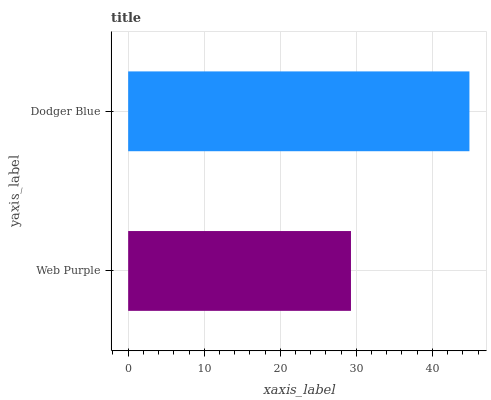Is Web Purple the minimum?
Answer yes or no. Yes. Is Dodger Blue the maximum?
Answer yes or no. Yes. Is Dodger Blue the minimum?
Answer yes or no. No. Is Dodger Blue greater than Web Purple?
Answer yes or no. Yes. Is Web Purple less than Dodger Blue?
Answer yes or no. Yes. Is Web Purple greater than Dodger Blue?
Answer yes or no. No. Is Dodger Blue less than Web Purple?
Answer yes or no. No. Is Dodger Blue the high median?
Answer yes or no. Yes. Is Web Purple the low median?
Answer yes or no. Yes. Is Web Purple the high median?
Answer yes or no. No. Is Dodger Blue the low median?
Answer yes or no. No. 